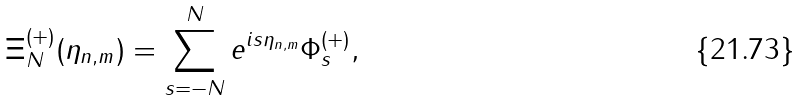Convert formula to latex. <formula><loc_0><loc_0><loc_500><loc_500>\Xi ^ { ( + ) } _ { N } ( \eta _ { n , m } ) = \sum _ { s = - N } ^ { N } e ^ { i s \eta _ { n , m } } \Phi ^ { ( + ) } _ { s } ,</formula> 